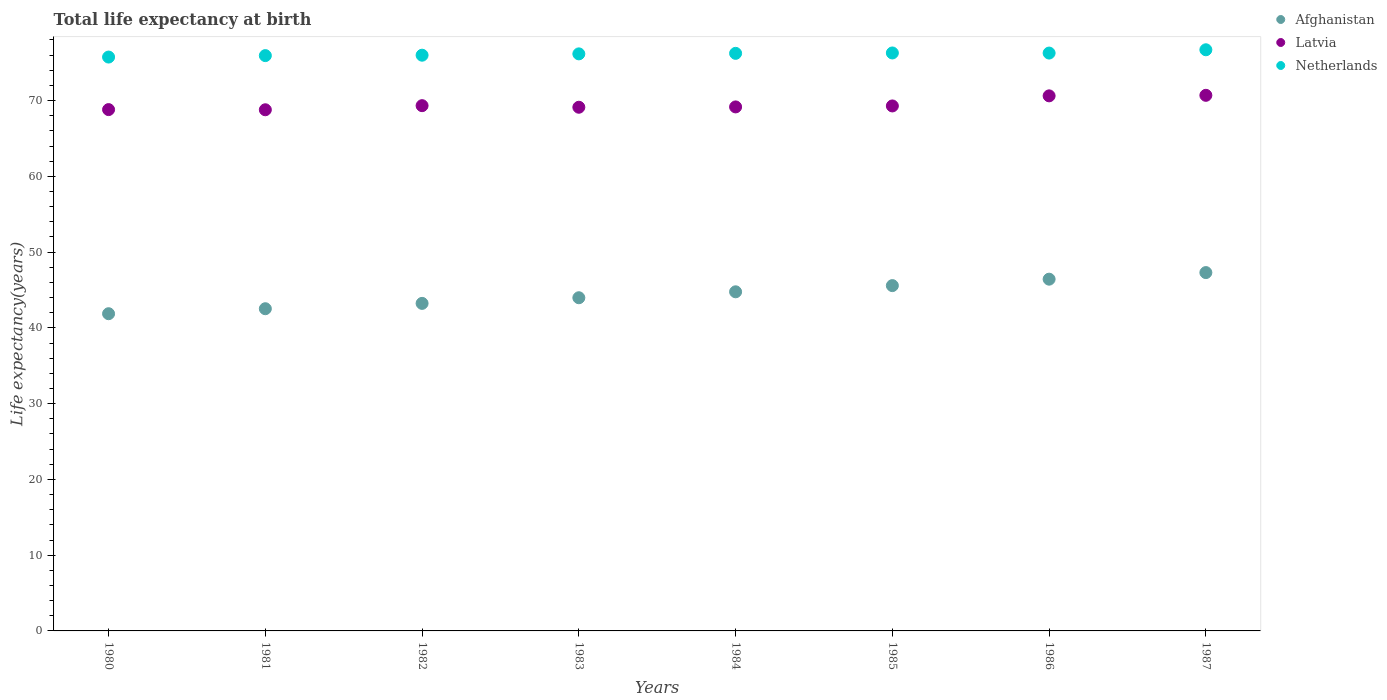What is the life expectancy at birth in in Latvia in 1983?
Offer a terse response. 69.12. Across all years, what is the maximum life expectancy at birth in in Latvia?
Offer a very short reply. 70.69. Across all years, what is the minimum life expectancy at birth in in Netherlands?
Make the answer very short. 75.74. In which year was the life expectancy at birth in in Afghanistan maximum?
Your answer should be very brief. 1987. What is the total life expectancy at birth in in Netherlands in the graph?
Provide a succinct answer. 609.32. What is the difference between the life expectancy at birth in in Afghanistan in 1980 and that in 1982?
Your response must be concise. -1.36. What is the difference between the life expectancy at birth in in Netherlands in 1981 and the life expectancy at birth in in Latvia in 1986?
Offer a terse response. 5.31. What is the average life expectancy at birth in in Afghanistan per year?
Provide a short and direct response. 44.46. In the year 1985, what is the difference between the life expectancy at birth in in Afghanistan and life expectancy at birth in in Netherlands?
Make the answer very short. -30.71. In how many years, is the life expectancy at birth in in Netherlands greater than 28 years?
Offer a very short reply. 8. What is the ratio of the life expectancy at birth in in Latvia in 1980 to that in 1987?
Keep it short and to the point. 0.97. Is the life expectancy at birth in in Netherlands in 1985 less than that in 1987?
Your response must be concise. Yes. What is the difference between the highest and the second highest life expectancy at birth in in Afghanistan?
Make the answer very short. 0.87. What is the difference between the highest and the lowest life expectancy at birth in in Afghanistan?
Provide a succinct answer. 5.43. In how many years, is the life expectancy at birth in in Netherlands greater than the average life expectancy at birth in in Netherlands taken over all years?
Make the answer very short. 4. Does the life expectancy at birth in in Afghanistan monotonically increase over the years?
Your response must be concise. Yes. Is the life expectancy at birth in in Latvia strictly less than the life expectancy at birth in in Afghanistan over the years?
Your answer should be compact. No. How many dotlines are there?
Your answer should be very brief. 3. Are the values on the major ticks of Y-axis written in scientific E-notation?
Provide a short and direct response. No. Where does the legend appear in the graph?
Give a very brief answer. Top right. How are the legend labels stacked?
Provide a short and direct response. Vertical. What is the title of the graph?
Offer a terse response. Total life expectancy at birth. What is the label or title of the Y-axis?
Your answer should be compact. Life expectancy(years). What is the Life expectancy(years) in Afghanistan in 1980?
Ensure brevity in your answer.  41.87. What is the Life expectancy(years) in Latvia in 1980?
Your response must be concise. 68.81. What is the Life expectancy(years) of Netherlands in 1980?
Your answer should be very brief. 75.74. What is the Life expectancy(years) of Afghanistan in 1981?
Make the answer very short. 42.53. What is the Life expectancy(years) of Latvia in 1981?
Offer a terse response. 68.79. What is the Life expectancy(years) in Netherlands in 1981?
Offer a terse response. 75.93. What is the Life expectancy(years) in Afghanistan in 1982?
Ensure brevity in your answer.  43.23. What is the Life expectancy(years) in Latvia in 1982?
Provide a short and direct response. 69.33. What is the Life expectancy(years) of Netherlands in 1982?
Ensure brevity in your answer.  75.99. What is the Life expectancy(years) of Afghanistan in 1983?
Make the answer very short. 43.98. What is the Life expectancy(years) of Latvia in 1983?
Your response must be concise. 69.12. What is the Life expectancy(years) in Netherlands in 1983?
Offer a terse response. 76.16. What is the Life expectancy(years) in Afghanistan in 1984?
Keep it short and to the point. 44.76. What is the Life expectancy(years) in Latvia in 1984?
Ensure brevity in your answer.  69.16. What is the Life expectancy(years) in Netherlands in 1984?
Give a very brief answer. 76.23. What is the Life expectancy(years) of Afghanistan in 1985?
Your answer should be compact. 45.58. What is the Life expectancy(years) in Latvia in 1985?
Keep it short and to the point. 69.29. What is the Life expectancy(years) of Netherlands in 1985?
Your answer should be compact. 76.28. What is the Life expectancy(years) of Afghanistan in 1986?
Offer a terse response. 46.43. What is the Life expectancy(years) in Latvia in 1986?
Make the answer very short. 70.62. What is the Life expectancy(years) of Netherlands in 1986?
Provide a succinct answer. 76.27. What is the Life expectancy(years) in Afghanistan in 1987?
Provide a succinct answer. 47.3. What is the Life expectancy(years) of Latvia in 1987?
Offer a very short reply. 70.69. What is the Life expectancy(years) in Netherlands in 1987?
Give a very brief answer. 76.71. Across all years, what is the maximum Life expectancy(years) in Afghanistan?
Keep it short and to the point. 47.3. Across all years, what is the maximum Life expectancy(years) of Latvia?
Make the answer very short. 70.69. Across all years, what is the maximum Life expectancy(years) of Netherlands?
Provide a short and direct response. 76.71. Across all years, what is the minimum Life expectancy(years) in Afghanistan?
Keep it short and to the point. 41.87. Across all years, what is the minimum Life expectancy(years) in Latvia?
Make the answer very short. 68.79. Across all years, what is the minimum Life expectancy(years) in Netherlands?
Your answer should be compact. 75.74. What is the total Life expectancy(years) in Afghanistan in the graph?
Keep it short and to the point. 355.66. What is the total Life expectancy(years) in Latvia in the graph?
Your answer should be compact. 555.81. What is the total Life expectancy(years) of Netherlands in the graph?
Provide a short and direct response. 609.32. What is the difference between the Life expectancy(years) of Afghanistan in 1980 and that in 1981?
Your answer should be very brief. -0.66. What is the difference between the Life expectancy(years) in Latvia in 1980 and that in 1981?
Your answer should be compact. 0.02. What is the difference between the Life expectancy(years) of Netherlands in 1980 and that in 1981?
Your answer should be very brief. -0.19. What is the difference between the Life expectancy(years) of Afghanistan in 1980 and that in 1982?
Make the answer very short. -1.36. What is the difference between the Life expectancy(years) of Latvia in 1980 and that in 1982?
Your answer should be compact. -0.52. What is the difference between the Life expectancy(years) of Netherlands in 1980 and that in 1982?
Keep it short and to the point. -0.25. What is the difference between the Life expectancy(years) of Afghanistan in 1980 and that in 1983?
Provide a short and direct response. -2.11. What is the difference between the Life expectancy(years) in Latvia in 1980 and that in 1983?
Provide a short and direct response. -0.31. What is the difference between the Life expectancy(years) of Netherlands in 1980 and that in 1983?
Provide a succinct answer. -0.42. What is the difference between the Life expectancy(years) of Afghanistan in 1980 and that in 1984?
Your answer should be compact. -2.89. What is the difference between the Life expectancy(years) in Latvia in 1980 and that in 1984?
Provide a short and direct response. -0.35. What is the difference between the Life expectancy(years) of Netherlands in 1980 and that in 1984?
Give a very brief answer. -0.49. What is the difference between the Life expectancy(years) in Afghanistan in 1980 and that in 1985?
Provide a succinct answer. -3.71. What is the difference between the Life expectancy(years) in Latvia in 1980 and that in 1985?
Keep it short and to the point. -0.48. What is the difference between the Life expectancy(years) in Netherlands in 1980 and that in 1985?
Your response must be concise. -0.54. What is the difference between the Life expectancy(years) in Afghanistan in 1980 and that in 1986?
Offer a terse response. -4.56. What is the difference between the Life expectancy(years) of Latvia in 1980 and that in 1986?
Give a very brief answer. -1.81. What is the difference between the Life expectancy(years) in Netherlands in 1980 and that in 1986?
Offer a very short reply. -0.53. What is the difference between the Life expectancy(years) in Afghanistan in 1980 and that in 1987?
Offer a terse response. -5.43. What is the difference between the Life expectancy(years) in Latvia in 1980 and that in 1987?
Keep it short and to the point. -1.88. What is the difference between the Life expectancy(years) in Netherlands in 1980 and that in 1987?
Your answer should be very brief. -0.96. What is the difference between the Life expectancy(years) in Afghanistan in 1981 and that in 1982?
Your answer should be very brief. -0.7. What is the difference between the Life expectancy(years) of Latvia in 1981 and that in 1982?
Your response must be concise. -0.54. What is the difference between the Life expectancy(years) in Netherlands in 1981 and that in 1982?
Your response must be concise. -0.05. What is the difference between the Life expectancy(years) in Afghanistan in 1981 and that in 1983?
Offer a terse response. -1.45. What is the difference between the Life expectancy(years) in Latvia in 1981 and that in 1983?
Your answer should be compact. -0.33. What is the difference between the Life expectancy(years) in Netherlands in 1981 and that in 1983?
Keep it short and to the point. -0.23. What is the difference between the Life expectancy(years) in Afghanistan in 1981 and that in 1984?
Your answer should be very brief. -2.23. What is the difference between the Life expectancy(years) of Latvia in 1981 and that in 1984?
Ensure brevity in your answer.  -0.38. What is the difference between the Life expectancy(years) of Netherlands in 1981 and that in 1984?
Offer a very short reply. -0.3. What is the difference between the Life expectancy(years) in Afghanistan in 1981 and that in 1985?
Give a very brief answer. -3.05. What is the difference between the Life expectancy(years) of Latvia in 1981 and that in 1985?
Give a very brief answer. -0.51. What is the difference between the Life expectancy(years) of Netherlands in 1981 and that in 1985?
Ensure brevity in your answer.  -0.35. What is the difference between the Life expectancy(years) of Afghanistan in 1981 and that in 1986?
Your answer should be very brief. -3.9. What is the difference between the Life expectancy(years) of Latvia in 1981 and that in 1986?
Offer a very short reply. -1.84. What is the difference between the Life expectancy(years) in Netherlands in 1981 and that in 1986?
Make the answer very short. -0.34. What is the difference between the Life expectancy(years) of Afghanistan in 1981 and that in 1987?
Provide a succinct answer. -4.77. What is the difference between the Life expectancy(years) of Latvia in 1981 and that in 1987?
Offer a very short reply. -1.91. What is the difference between the Life expectancy(years) in Netherlands in 1981 and that in 1987?
Your answer should be compact. -0.77. What is the difference between the Life expectancy(years) of Afghanistan in 1982 and that in 1983?
Offer a very short reply. -0.75. What is the difference between the Life expectancy(years) of Latvia in 1982 and that in 1983?
Give a very brief answer. 0.21. What is the difference between the Life expectancy(years) in Netherlands in 1982 and that in 1983?
Make the answer very short. -0.18. What is the difference between the Life expectancy(years) in Afghanistan in 1982 and that in 1984?
Your response must be concise. -1.53. What is the difference between the Life expectancy(years) of Latvia in 1982 and that in 1984?
Your response must be concise. 0.17. What is the difference between the Life expectancy(years) of Netherlands in 1982 and that in 1984?
Your response must be concise. -0.24. What is the difference between the Life expectancy(years) in Afghanistan in 1982 and that in 1985?
Provide a short and direct response. -2.35. What is the difference between the Life expectancy(years) in Latvia in 1982 and that in 1985?
Give a very brief answer. 0.04. What is the difference between the Life expectancy(years) in Netherlands in 1982 and that in 1985?
Your answer should be very brief. -0.3. What is the difference between the Life expectancy(years) in Afghanistan in 1982 and that in 1986?
Provide a succinct answer. -3.2. What is the difference between the Life expectancy(years) in Latvia in 1982 and that in 1986?
Give a very brief answer. -1.29. What is the difference between the Life expectancy(years) of Netherlands in 1982 and that in 1986?
Make the answer very short. -0.28. What is the difference between the Life expectancy(years) in Afghanistan in 1982 and that in 1987?
Offer a terse response. -4.07. What is the difference between the Life expectancy(years) in Latvia in 1982 and that in 1987?
Keep it short and to the point. -1.36. What is the difference between the Life expectancy(years) in Netherlands in 1982 and that in 1987?
Keep it short and to the point. -0.72. What is the difference between the Life expectancy(years) of Afghanistan in 1983 and that in 1984?
Your answer should be very brief. -0.78. What is the difference between the Life expectancy(years) of Latvia in 1983 and that in 1984?
Your answer should be compact. -0.04. What is the difference between the Life expectancy(years) of Netherlands in 1983 and that in 1984?
Provide a succinct answer. -0.07. What is the difference between the Life expectancy(years) in Afghanistan in 1983 and that in 1985?
Provide a succinct answer. -1.6. What is the difference between the Life expectancy(years) in Latvia in 1983 and that in 1985?
Your answer should be compact. -0.17. What is the difference between the Life expectancy(years) of Netherlands in 1983 and that in 1985?
Your answer should be very brief. -0.12. What is the difference between the Life expectancy(years) in Afghanistan in 1983 and that in 1986?
Provide a succinct answer. -2.45. What is the difference between the Life expectancy(years) of Latvia in 1983 and that in 1986?
Provide a succinct answer. -1.5. What is the difference between the Life expectancy(years) in Netherlands in 1983 and that in 1986?
Ensure brevity in your answer.  -0.11. What is the difference between the Life expectancy(years) of Afghanistan in 1983 and that in 1987?
Keep it short and to the point. -3.32. What is the difference between the Life expectancy(years) in Latvia in 1983 and that in 1987?
Make the answer very short. -1.57. What is the difference between the Life expectancy(years) in Netherlands in 1983 and that in 1987?
Offer a terse response. -0.54. What is the difference between the Life expectancy(years) of Afghanistan in 1984 and that in 1985?
Offer a very short reply. -0.82. What is the difference between the Life expectancy(years) of Latvia in 1984 and that in 1985?
Offer a very short reply. -0.13. What is the difference between the Life expectancy(years) in Netherlands in 1984 and that in 1985?
Your response must be concise. -0.05. What is the difference between the Life expectancy(years) of Afghanistan in 1984 and that in 1986?
Offer a very short reply. -1.67. What is the difference between the Life expectancy(years) in Latvia in 1984 and that in 1986?
Your answer should be compact. -1.46. What is the difference between the Life expectancy(years) in Netherlands in 1984 and that in 1986?
Give a very brief answer. -0.04. What is the difference between the Life expectancy(years) of Afghanistan in 1984 and that in 1987?
Provide a succinct answer. -2.54. What is the difference between the Life expectancy(years) in Latvia in 1984 and that in 1987?
Offer a very short reply. -1.53. What is the difference between the Life expectancy(years) of Netherlands in 1984 and that in 1987?
Your answer should be compact. -0.47. What is the difference between the Life expectancy(years) in Afghanistan in 1985 and that in 1986?
Offer a terse response. -0.85. What is the difference between the Life expectancy(years) of Latvia in 1985 and that in 1986?
Provide a succinct answer. -1.33. What is the difference between the Life expectancy(years) in Netherlands in 1985 and that in 1986?
Provide a short and direct response. 0.01. What is the difference between the Life expectancy(years) in Afghanistan in 1985 and that in 1987?
Provide a short and direct response. -1.72. What is the difference between the Life expectancy(years) of Latvia in 1985 and that in 1987?
Offer a very short reply. -1.4. What is the difference between the Life expectancy(years) of Netherlands in 1985 and that in 1987?
Offer a terse response. -0.42. What is the difference between the Life expectancy(years) in Afghanistan in 1986 and that in 1987?
Provide a short and direct response. -0.87. What is the difference between the Life expectancy(years) in Latvia in 1986 and that in 1987?
Give a very brief answer. -0.07. What is the difference between the Life expectancy(years) of Netherlands in 1986 and that in 1987?
Provide a succinct answer. -0.43. What is the difference between the Life expectancy(years) of Afghanistan in 1980 and the Life expectancy(years) of Latvia in 1981?
Your answer should be very brief. -26.92. What is the difference between the Life expectancy(years) of Afghanistan in 1980 and the Life expectancy(years) of Netherlands in 1981?
Make the answer very short. -34.07. What is the difference between the Life expectancy(years) of Latvia in 1980 and the Life expectancy(years) of Netherlands in 1981?
Ensure brevity in your answer.  -7.13. What is the difference between the Life expectancy(years) of Afghanistan in 1980 and the Life expectancy(years) of Latvia in 1982?
Offer a very short reply. -27.46. What is the difference between the Life expectancy(years) of Afghanistan in 1980 and the Life expectancy(years) of Netherlands in 1982?
Provide a succinct answer. -34.12. What is the difference between the Life expectancy(years) in Latvia in 1980 and the Life expectancy(years) in Netherlands in 1982?
Offer a very short reply. -7.18. What is the difference between the Life expectancy(years) in Afghanistan in 1980 and the Life expectancy(years) in Latvia in 1983?
Give a very brief answer. -27.25. What is the difference between the Life expectancy(years) of Afghanistan in 1980 and the Life expectancy(years) of Netherlands in 1983?
Your answer should be very brief. -34.3. What is the difference between the Life expectancy(years) of Latvia in 1980 and the Life expectancy(years) of Netherlands in 1983?
Give a very brief answer. -7.36. What is the difference between the Life expectancy(years) in Afghanistan in 1980 and the Life expectancy(years) in Latvia in 1984?
Your answer should be compact. -27.3. What is the difference between the Life expectancy(years) of Afghanistan in 1980 and the Life expectancy(years) of Netherlands in 1984?
Keep it short and to the point. -34.37. What is the difference between the Life expectancy(years) in Latvia in 1980 and the Life expectancy(years) in Netherlands in 1984?
Your response must be concise. -7.42. What is the difference between the Life expectancy(years) in Afghanistan in 1980 and the Life expectancy(years) in Latvia in 1985?
Give a very brief answer. -27.42. What is the difference between the Life expectancy(years) of Afghanistan in 1980 and the Life expectancy(years) of Netherlands in 1985?
Your answer should be very brief. -34.42. What is the difference between the Life expectancy(years) of Latvia in 1980 and the Life expectancy(years) of Netherlands in 1985?
Provide a succinct answer. -7.48. What is the difference between the Life expectancy(years) of Afghanistan in 1980 and the Life expectancy(years) of Latvia in 1986?
Provide a short and direct response. -28.75. What is the difference between the Life expectancy(years) in Afghanistan in 1980 and the Life expectancy(years) in Netherlands in 1986?
Give a very brief answer. -34.4. What is the difference between the Life expectancy(years) of Latvia in 1980 and the Life expectancy(years) of Netherlands in 1986?
Offer a very short reply. -7.46. What is the difference between the Life expectancy(years) in Afghanistan in 1980 and the Life expectancy(years) in Latvia in 1987?
Give a very brief answer. -28.83. What is the difference between the Life expectancy(years) in Afghanistan in 1980 and the Life expectancy(years) in Netherlands in 1987?
Provide a short and direct response. -34.84. What is the difference between the Life expectancy(years) of Latvia in 1980 and the Life expectancy(years) of Netherlands in 1987?
Your answer should be compact. -7.9. What is the difference between the Life expectancy(years) of Afghanistan in 1981 and the Life expectancy(years) of Latvia in 1982?
Your answer should be very brief. -26.8. What is the difference between the Life expectancy(years) in Afghanistan in 1981 and the Life expectancy(years) in Netherlands in 1982?
Ensure brevity in your answer.  -33.46. What is the difference between the Life expectancy(years) in Latvia in 1981 and the Life expectancy(years) in Netherlands in 1982?
Your answer should be compact. -7.2. What is the difference between the Life expectancy(years) in Afghanistan in 1981 and the Life expectancy(years) in Latvia in 1983?
Keep it short and to the point. -26.59. What is the difference between the Life expectancy(years) of Afghanistan in 1981 and the Life expectancy(years) of Netherlands in 1983?
Ensure brevity in your answer.  -33.64. What is the difference between the Life expectancy(years) in Latvia in 1981 and the Life expectancy(years) in Netherlands in 1983?
Offer a very short reply. -7.38. What is the difference between the Life expectancy(years) in Afghanistan in 1981 and the Life expectancy(years) in Latvia in 1984?
Offer a terse response. -26.64. What is the difference between the Life expectancy(years) in Afghanistan in 1981 and the Life expectancy(years) in Netherlands in 1984?
Your answer should be compact. -33.71. What is the difference between the Life expectancy(years) in Latvia in 1981 and the Life expectancy(years) in Netherlands in 1984?
Your response must be concise. -7.45. What is the difference between the Life expectancy(years) of Afghanistan in 1981 and the Life expectancy(years) of Latvia in 1985?
Your response must be concise. -26.76. What is the difference between the Life expectancy(years) in Afghanistan in 1981 and the Life expectancy(years) in Netherlands in 1985?
Provide a short and direct response. -33.76. What is the difference between the Life expectancy(years) in Latvia in 1981 and the Life expectancy(years) in Netherlands in 1985?
Make the answer very short. -7.5. What is the difference between the Life expectancy(years) in Afghanistan in 1981 and the Life expectancy(years) in Latvia in 1986?
Make the answer very short. -28.1. What is the difference between the Life expectancy(years) of Afghanistan in 1981 and the Life expectancy(years) of Netherlands in 1986?
Make the answer very short. -33.74. What is the difference between the Life expectancy(years) of Latvia in 1981 and the Life expectancy(years) of Netherlands in 1986?
Ensure brevity in your answer.  -7.48. What is the difference between the Life expectancy(years) in Afghanistan in 1981 and the Life expectancy(years) in Latvia in 1987?
Offer a very short reply. -28.17. What is the difference between the Life expectancy(years) of Afghanistan in 1981 and the Life expectancy(years) of Netherlands in 1987?
Your response must be concise. -34.18. What is the difference between the Life expectancy(years) in Latvia in 1981 and the Life expectancy(years) in Netherlands in 1987?
Offer a very short reply. -7.92. What is the difference between the Life expectancy(years) of Afghanistan in 1982 and the Life expectancy(years) of Latvia in 1983?
Ensure brevity in your answer.  -25.89. What is the difference between the Life expectancy(years) in Afghanistan in 1982 and the Life expectancy(years) in Netherlands in 1983?
Your answer should be very brief. -32.93. What is the difference between the Life expectancy(years) in Latvia in 1982 and the Life expectancy(years) in Netherlands in 1983?
Provide a succinct answer. -6.84. What is the difference between the Life expectancy(years) of Afghanistan in 1982 and the Life expectancy(years) of Latvia in 1984?
Give a very brief answer. -25.93. What is the difference between the Life expectancy(years) in Afghanistan in 1982 and the Life expectancy(years) in Netherlands in 1984?
Keep it short and to the point. -33. What is the difference between the Life expectancy(years) of Latvia in 1982 and the Life expectancy(years) of Netherlands in 1984?
Your response must be concise. -6.9. What is the difference between the Life expectancy(years) of Afghanistan in 1982 and the Life expectancy(years) of Latvia in 1985?
Offer a very short reply. -26.06. What is the difference between the Life expectancy(years) of Afghanistan in 1982 and the Life expectancy(years) of Netherlands in 1985?
Give a very brief answer. -33.05. What is the difference between the Life expectancy(years) in Latvia in 1982 and the Life expectancy(years) in Netherlands in 1985?
Provide a succinct answer. -6.96. What is the difference between the Life expectancy(years) in Afghanistan in 1982 and the Life expectancy(years) in Latvia in 1986?
Provide a short and direct response. -27.39. What is the difference between the Life expectancy(years) in Afghanistan in 1982 and the Life expectancy(years) in Netherlands in 1986?
Your answer should be compact. -33.04. What is the difference between the Life expectancy(years) of Latvia in 1982 and the Life expectancy(years) of Netherlands in 1986?
Provide a short and direct response. -6.94. What is the difference between the Life expectancy(years) of Afghanistan in 1982 and the Life expectancy(years) of Latvia in 1987?
Provide a short and direct response. -27.46. What is the difference between the Life expectancy(years) of Afghanistan in 1982 and the Life expectancy(years) of Netherlands in 1987?
Ensure brevity in your answer.  -33.47. What is the difference between the Life expectancy(years) of Latvia in 1982 and the Life expectancy(years) of Netherlands in 1987?
Your response must be concise. -7.38. What is the difference between the Life expectancy(years) in Afghanistan in 1983 and the Life expectancy(years) in Latvia in 1984?
Provide a succinct answer. -25.19. What is the difference between the Life expectancy(years) of Afghanistan in 1983 and the Life expectancy(years) of Netherlands in 1984?
Offer a terse response. -32.26. What is the difference between the Life expectancy(years) in Latvia in 1983 and the Life expectancy(years) in Netherlands in 1984?
Provide a succinct answer. -7.11. What is the difference between the Life expectancy(years) of Afghanistan in 1983 and the Life expectancy(years) of Latvia in 1985?
Keep it short and to the point. -25.32. What is the difference between the Life expectancy(years) of Afghanistan in 1983 and the Life expectancy(years) of Netherlands in 1985?
Ensure brevity in your answer.  -32.31. What is the difference between the Life expectancy(years) of Latvia in 1983 and the Life expectancy(years) of Netherlands in 1985?
Your answer should be compact. -7.17. What is the difference between the Life expectancy(years) of Afghanistan in 1983 and the Life expectancy(years) of Latvia in 1986?
Make the answer very short. -26.65. What is the difference between the Life expectancy(years) of Afghanistan in 1983 and the Life expectancy(years) of Netherlands in 1986?
Make the answer very short. -32.29. What is the difference between the Life expectancy(years) in Latvia in 1983 and the Life expectancy(years) in Netherlands in 1986?
Your answer should be compact. -7.15. What is the difference between the Life expectancy(years) of Afghanistan in 1983 and the Life expectancy(years) of Latvia in 1987?
Ensure brevity in your answer.  -26.72. What is the difference between the Life expectancy(years) of Afghanistan in 1983 and the Life expectancy(years) of Netherlands in 1987?
Keep it short and to the point. -32.73. What is the difference between the Life expectancy(years) of Latvia in 1983 and the Life expectancy(years) of Netherlands in 1987?
Provide a short and direct response. -7.59. What is the difference between the Life expectancy(years) in Afghanistan in 1984 and the Life expectancy(years) in Latvia in 1985?
Keep it short and to the point. -24.53. What is the difference between the Life expectancy(years) in Afghanistan in 1984 and the Life expectancy(years) in Netherlands in 1985?
Your answer should be compact. -31.53. What is the difference between the Life expectancy(years) in Latvia in 1984 and the Life expectancy(years) in Netherlands in 1985?
Your answer should be very brief. -7.12. What is the difference between the Life expectancy(years) of Afghanistan in 1984 and the Life expectancy(years) of Latvia in 1986?
Your answer should be compact. -25.86. What is the difference between the Life expectancy(years) of Afghanistan in 1984 and the Life expectancy(years) of Netherlands in 1986?
Provide a succinct answer. -31.51. What is the difference between the Life expectancy(years) in Latvia in 1984 and the Life expectancy(years) in Netherlands in 1986?
Provide a short and direct response. -7.11. What is the difference between the Life expectancy(years) of Afghanistan in 1984 and the Life expectancy(years) of Latvia in 1987?
Provide a short and direct response. -25.93. What is the difference between the Life expectancy(years) in Afghanistan in 1984 and the Life expectancy(years) in Netherlands in 1987?
Ensure brevity in your answer.  -31.95. What is the difference between the Life expectancy(years) of Latvia in 1984 and the Life expectancy(years) of Netherlands in 1987?
Your answer should be compact. -7.54. What is the difference between the Life expectancy(years) in Afghanistan in 1985 and the Life expectancy(years) in Latvia in 1986?
Your answer should be compact. -25.05. What is the difference between the Life expectancy(years) of Afghanistan in 1985 and the Life expectancy(years) of Netherlands in 1986?
Keep it short and to the point. -30.69. What is the difference between the Life expectancy(years) of Latvia in 1985 and the Life expectancy(years) of Netherlands in 1986?
Offer a terse response. -6.98. What is the difference between the Life expectancy(years) of Afghanistan in 1985 and the Life expectancy(years) of Latvia in 1987?
Keep it short and to the point. -25.12. What is the difference between the Life expectancy(years) of Afghanistan in 1985 and the Life expectancy(years) of Netherlands in 1987?
Keep it short and to the point. -31.13. What is the difference between the Life expectancy(years) of Latvia in 1985 and the Life expectancy(years) of Netherlands in 1987?
Your answer should be compact. -7.41. What is the difference between the Life expectancy(years) in Afghanistan in 1986 and the Life expectancy(years) in Latvia in 1987?
Ensure brevity in your answer.  -24.27. What is the difference between the Life expectancy(years) in Afghanistan in 1986 and the Life expectancy(years) in Netherlands in 1987?
Ensure brevity in your answer.  -30.28. What is the difference between the Life expectancy(years) in Latvia in 1986 and the Life expectancy(years) in Netherlands in 1987?
Your answer should be compact. -6.08. What is the average Life expectancy(years) in Afghanistan per year?
Offer a very short reply. 44.46. What is the average Life expectancy(years) of Latvia per year?
Provide a succinct answer. 69.48. What is the average Life expectancy(years) of Netherlands per year?
Ensure brevity in your answer.  76.17. In the year 1980, what is the difference between the Life expectancy(years) in Afghanistan and Life expectancy(years) in Latvia?
Make the answer very short. -26.94. In the year 1980, what is the difference between the Life expectancy(years) of Afghanistan and Life expectancy(years) of Netherlands?
Your response must be concise. -33.88. In the year 1980, what is the difference between the Life expectancy(years) of Latvia and Life expectancy(years) of Netherlands?
Offer a very short reply. -6.93. In the year 1981, what is the difference between the Life expectancy(years) of Afghanistan and Life expectancy(years) of Latvia?
Ensure brevity in your answer.  -26.26. In the year 1981, what is the difference between the Life expectancy(years) in Afghanistan and Life expectancy(years) in Netherlands?
Your response must be concise. -33.41. In the year 1981, what is the difference between the Life expectancy(years) in Latvia and Life expectancy(years) in Netherlands?
Provide a short and direct response. -7.15. In the year 1982, what is the difference between the Life expectancy(years) in Afghanistan and Life expectancy(years) in Latvia?
Provide a succinct answer. -26.1. In the year 1982, what is the difference between the Life expectancy(years) in Afghanistan and Life expectancy(years) in Netherlands?
Offer a very short reply. -32.76. In the year 1982, what is the difference between the Life expectancy(years) in Latvia and Life expectancy(years) in Netherlands?
Your answer should be compact. -6.66. In the year 1983, what is the difference between the Life expectancy(years) of Afghanistan and Life expectancy(years) of Latvia?
Give a very brief answer. -25.14. In the year 1983, what is the difference between the Life expectancy(years) of Afghanistan and Life expectancy(years) of Netherlands?
Give a very brief answer. -32.19. In the year 1983, what is the difference between the Life expectancy(years) of Latvia and Life expectancy(years) of Netherlands?
Your response must be concise. -7.05. In the year 1984, what is the difference between the Life expectancy(years) of Afghanistan and Life expectancy(years) of Latvia?
Offer a very short reply. -24.4. In the year 1984, what is the difference between the Life expectancy(years) of Afghanistan and Life expectancy(years) of Netherlands?
Keep it short and to the point. -31.47. In the year 1984, what is the difference between the Life expectancy(years) in Latvia and Life expectancy(years) in Netherlands?
Offer a very short reply. -7.07. In the year 1985, what is the difference between the Life expectancy(years) of Afghanistan and Life expectancy(years) of Latvia?
Provide a short and direct response. -23.71. In the year 1985, what is the difference between the Life expectancy(years) of Afghanistan and Life expectancy(years) of Netherlands?
Offer a terse response. -30.71. In the year 1985, what is the difference between the Life expectancy(years) in Latvia and Life expectancy(years) in Netherlands?
Offer a very short reply. -6.99. In the year 1986, what is the difference between the Life expectancy(years) of Afghanistan and Life expectancy(years) of Latvia?
Your answer should be very brief. -24.2. In the year 1986, what is the difference between the Life expectancy(years) in Afghanistan and Life expectancy(years) in Netherlands?
Make the answer very short. -29.84. In the year 1986, what is the difference between the Life expectancy(years) of Latvia and Life expectancy(years) of Netherlands?
Offer a terse response. -5.65. In the year 1987, what is the difference between the Life expectancy(years) in Afghanistan and Life expectancy(years) in Latvia?
Your answer should be compact. -23.4. In the year 1987, what is the difference between the Life expectancy(years) of Afghanistan and Life expectancy(years) of Netherlands?
Your answer should be compact. -29.41. In the year 1987, what is the difference between the Life expectancy(years) of Latvia and Life expectancy(years) of Netherlands?
Provide a short and direct response. -6.01. What is the ratio of the Life expectancy(years) in Afghanistan in 1980 to that in 1981?
Make the answer very short. 0.98. What is the ratio of the Life expectancy(years) in Afghanistan in 1980 to that in 1982?
Provide a succinct answer. 0.97. What is the ratio of the Life expectancy(years) in Latvia in 1980 to that in 1982?
Your response must be concise. 0.99. What is the ratio of the Life expectancy(years) in Afghanistan in 1980 to that in 1983?
Provide a short and direct response. 0.95. What is the ratio of the Life expectancy(years) in Netherlands in 1980 to that in 1983?
Offer a terse response. 0.99. What is the ratio of the Life expectancy(years) in Afghanistan in 1980 to that in 1984?
Provide a short and direct response. 0.94. What is the ratio of the Life expectancy(years) of Afghanistan in 1980 to that in 1985?
Provide a succinct answer. 0.92. What is the ratio of the Life expectancy(years) of Latvia in 1980 to that in 1985?
Provide a succinct answer. 0.99. What is the ratio of the Life expectancy(years) of Netherlands in 1980 to that in 1985?
Make the answer very short. 0.99. What is the ratio of the Life expectancy(years) in Afghanistan in 1980 to that in 1986?
Provide a short and direct response. 0.9. What is the ratio of the Life expectancy(years) of Latvia in 1980 to that in 1986?
Keep it short and to the point. 0.97. What is the ratio of the Life expectancy(years) of Netherlands in 1980 to that in 1986?
Offer a terse response. 0.99. What is the ratio of the Life expectancy(years) of Afghanistan in 1980 to that in 1987?
Keep it short and to the point. 0.89. What is the ratio of the Life expectancy(years) in Latvia in 1980 to that in 1987?
Your answer should be very brief. 0.97. What is the ratio of the Life expectancy(years) of Netherlands in 1980 to that in 1987?
Your answer should be very brief. 0.99. What is the ratio of the Life expectancy(years) in Afghanistan in 1981 to that in 1982?
Make the answer very short. 0.98. What is the ratio of the Life expectancy(years) in Latvia in 1981 to that in 1982?
Ensure brevity in your answer.  0.99. What is the ratio of the Life expectancy(years) in Afghanistan in 1981 to that in 1983?
Make the answer very short. 0.97. What is the ratio of the Life expectancy(years) in Afghanistan in 1981 to that in 1984?
Make the answer very short. 0.95. What is the ratio of the Life expectancy(years) in Afghanistan in 1981 to that in 1985?
Your response must be concise. 0.93. What is the ratio of the Life expectancy(years) of Netherlands in 1981 to that in 1985?
Make the answer very short. 1. What is the ratio of the Life expectancy(years) of Afghanistan in 1981 to that in 1986?
Offer a very short reply. 0.92. What is the ratio of the Life expectancy(years) of Afghanistan in 1981 to that in 1987?
Provide a succinct answer. 0.9. What is the ratio of the Life expectancy(years) in Afghanistan in 1982 to that in 1983?
Your answer should be compact. 0.98. What is the ratio of the Life expectancy(years) in Netherlands in 1982 to that in 1983?
Offer a terse response. 1. What is the ratio of the Life expectancy(years) in Afghanistan in 1982 to that in 1984?
Ensure brevity in your answer.  0.97. What is the ratio of the Life expectancy(years) of Afghanistan in 1982 to that in 1985?
Provide a succinct answer. 0.95. What is the ratio of the Life expectancy(years) of Latvia in 1982 to that in 1985?
Offer a terse response. 1. What is the ratio of the Life expectancy(years) of Afghanistan in 1982 to that in 1986?
Provide a succinct answer. 0.93. What is the ratio of the Life expectancy(years) of Latvia in 1982 to that in 1986?
Keep it short and to the point. 0.98. What is the ratio of the Life expectancy(years) of Netherlands in 1982 to that in 1986?
Provide a succinct answer. 1. What is the ratio of the Life expectancy(years) of Afghanistan in 1982 to that in 1987?
Your response must be concise. 0.91. What is the ratio of the Life expectancy(years) of Latvia in 1982 to that in 1987?
Offer a very short reply. 0.98. What is the ratio of the Life expectancy(years) in Afghanistan in 1983 to that in 1984?
Provide a short and direct response. 0.98. What is the ratio of the Life expectancy(years) of Latvia in 1983 to that in 1984?
Provide a succinct answer. 1. What is the ratio of the Life expectancy(years) in Netherlands in 1983 to that in 1984?
Your response must be concise. 1. What is the ratio of the Life expectancy(years) in Afghanistan in 1983 to that in 1985?
Your answer should be very brief. 0.96. What is the ratio of the Life expectancy(years) of Latvia in 1983 to that in 1985?
Offer a very short reply. 1. What is the ratio of the Life expectancy(years) of Afghanistan in 1983 to that in 1986?
Provide a succinct answer. 0.95. What is the ratio of the Life expectancy(years) of Latvia in 1983 to that in 1986?
Keep it short and to the point. 0.98. What is the ratio of the Life expectancy(years) of Afghanistan in 1983 to that in 1987?
Ensure brevity in your answer.  0.93. What is the ratio of the Life expectancy(years) in Latvia in 1983 to that in 1987?
Your answer should be very brief. 0.98. What is the ratio of the Life expectancy(years) of Netherlands in 1983 to that in 1987?
Your response must be concise. 0.99. What is the ratio of the Life expectancy(years) of Afghanistan in 1984 to that in 1985?
Offer a very short reply. 0.98. What is the ratio of the Life expectancy(years) of Latvia in 1984 to that in 1985?
Offer a very short reply. 1. What is the ratio of the Life expectancy(years) in Afghanistan in 1984 to that in 1986?
Your answer should be very brief. 0.96. What is the ratio of the Life expectancy(years) in Latvia in 1984 to that in 1986?
Provide a short and direct response. 0.98. What is the ratio of the Life expectancy(years) of Netherlands in 1984 to that in 1986?
Offer a terse response. 1. What is the ratio of the Life expectancy(years) in Afghanistan in 1984 to that in 1987?
Your answer should be very brief. 0.95. What is the ratio of the Life expectancy(years) of Latvia in 1984 to that in 1987?
Provide a short and direct response. 0.98. What is the ratio of the Life expectancy(years) of Afghanistan in 1985 to that in 1986?
Provide a short and direct response. 0.98. What is the ratio of the Life expectancy(years) in Latvia in 1985 to that in 1986?
Provide a short and direct response. 0.98. What is the ratio of the Life expectancy(years) in Afghanistan in 1985 to that in 1987?
Your answer should be compact. 0.96. What is the ratio of the Life expectancy(years) in Latvia in 1985 to that in 1987?
Offer a very short reply. 0.98. What is the ratio of the Life expectancy(years) in Afghanistan in 1986 to that in 1987?
Your answer should be very brief. 0.98. What is the difference between the highest and the second highest Life expectancy(years) in Afghanistan?
Give a very brief answer. 0.87. What is the difference between the highest and the second highest Life expectancy(years) of Latvia?
Your answer should be very brief. 0.07. What is the difference between the highest and the second highest Life expectancy(years) of Netherlands?
Make the answer very short. 0.42. What is the difference between the highest and the lowest Life expectancy(years) in Afghanistan?
Your response must be concise. 5.43. What is the difference between the highest and the lowest Life expectancy(years) of Latvia?
Offer a very short reply. 1.91. What is the difference between the highest and the lowest Life expectancy(years) in Netherlands?
Keep it short and to the point. 0.96. 